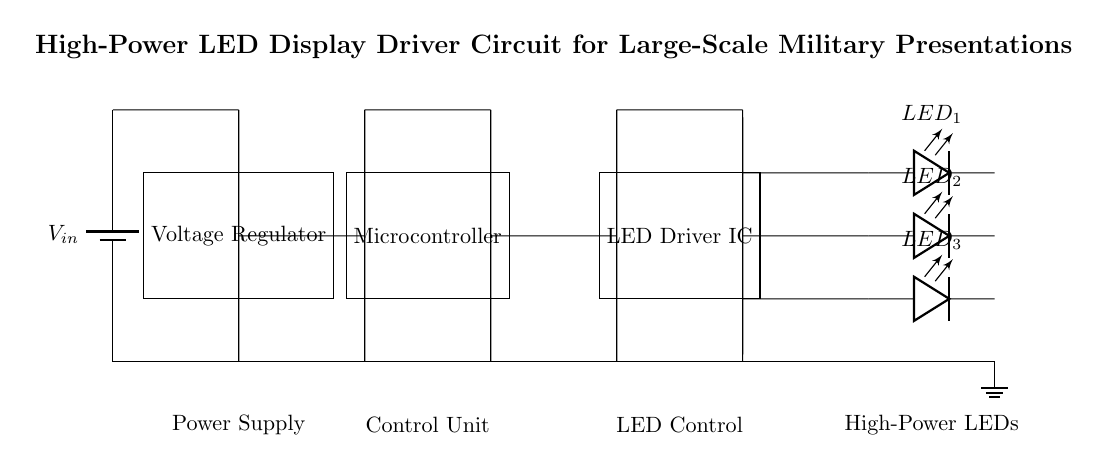What is the power supply labeled as? The power supply is labeled as \( V_{in} \), indicating the input voltage for the circuit.
Answer: \( V_{in} \) What type of component is used for regulation? The circuit includes a component labeled as a Voltage Regulator, which manages the voltage output for the circuit.
Answer: Voltage Regulator How many high-power LEDs are connected in the circuit? There are three high-power LEDs labeled as \( LED_1 \), \( LED_2 \), and \( LED_3 \), providing visual output for the display.
Answer: 3 What component controls the LED driver IC? The Microcontroller controls the LED Driver IC, which is responsible for managing the operation of the LEDs based on input signals.
Answer: Microcontroller What is the function of the ground in this circuit? The ground serves as the reference point for all voltage measurements in the circuit, ensuring safety and consistent operation of components.
Answer: Reference point What connects the voltage regulator to the microcontroller? A wire connects the Voltage Regulator to the Microcontroller, providing regulated power for the control unit to function.
Answer: Wire How is the LED Driver IC connected to the LEDs? The LED Driver IC is connected to the LEDs directly through wires that allow control signals to reach each LED, enabling them to light up.
Answer: Direct connection 